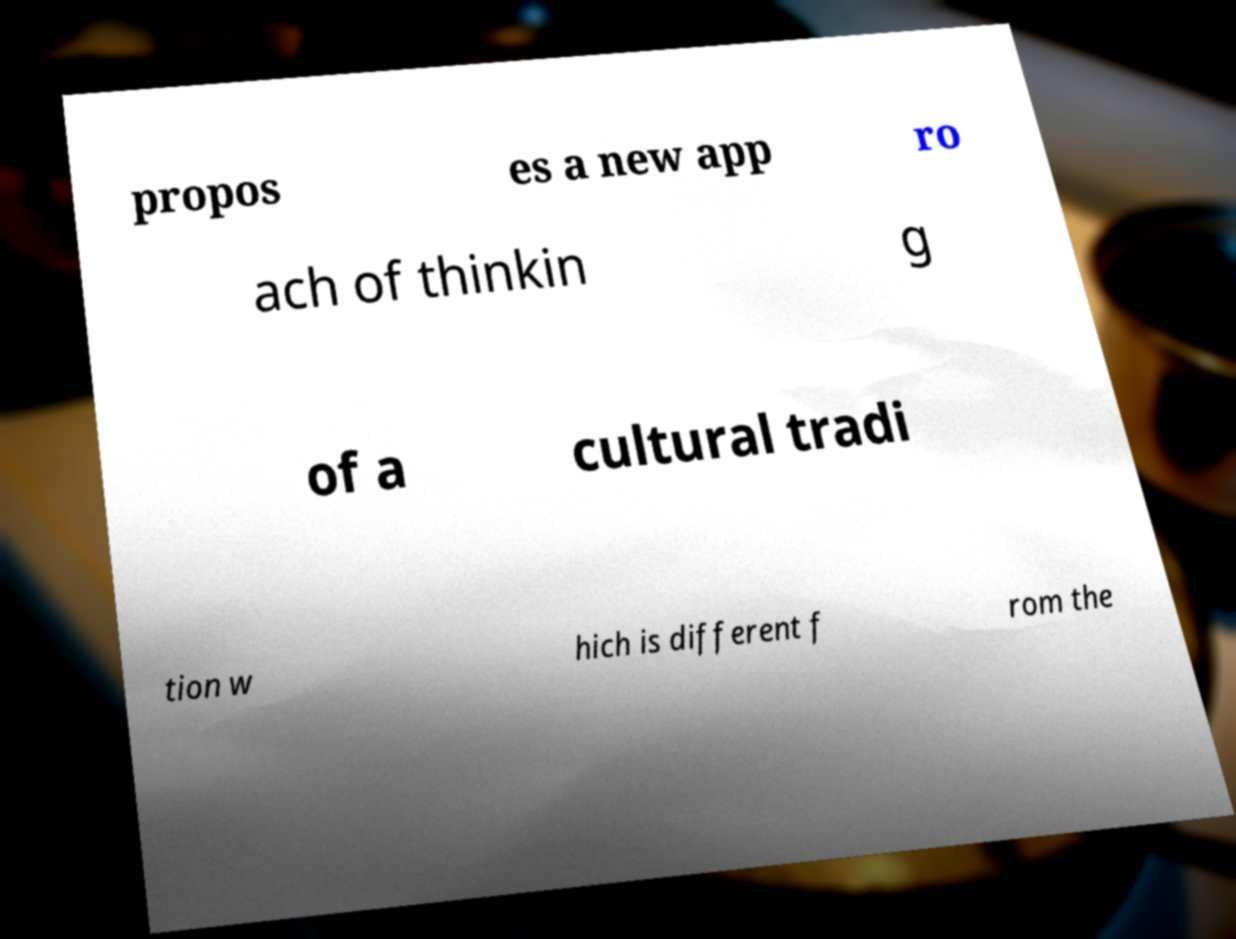For documentation purposes, I need the text within this image transcribed. Could you provide that? propos es a new app ro ach of thinkin g of a cultural tradi tion w hich is different f rom the 